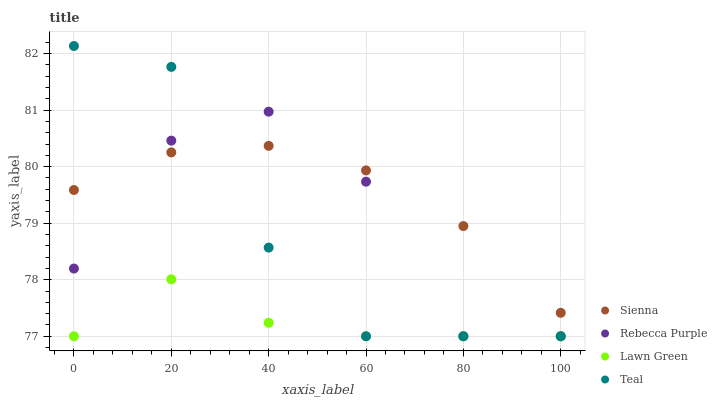Does Lawn Green have the minimum area under the curve?
Answer yes or no. Yes. Does Sienna have the maximum area under the curve?
Answer yes or no. Yes. Does Rebecca Purple have the minimum area under the curve?
Answer yes or no. No. Does Rebecca Purple have the maximum area under the curve?
Answer yes or no. No. Is Sienna the smoothest?
Answer yes or no. Yes. Is Rebecca Purple the roughest?
Answer yes or no. Yes. Is Lawn Green the smoothest?
Answer yes or no. No. Is Lawn Green the roughest?
Answer yes or no. No. Does Lawn Green have the lowest value?
Answer yes or no. Yes. Does Teal have the highest value?
Answer yes or no. Yes. Does Rebecca Purple have the highest value?
Answer yes or no. No. Is Lawn Green less than Sienna?
Answer yes or no. Yes. Is Sienna greater than Lawn Green?
Answer yes or no. Yes. Does Rebecca Purple intersect Lawn Green?
Answer yes or no. Yes. Is Rebecca Purple less than Lawn Green?
Answer yes or no. No. Is Rebecca Purple greater than Lawn Green?
Answer yes or no. No. Does Lawn Green intersect Sienna?
Answer yes or no. No. 